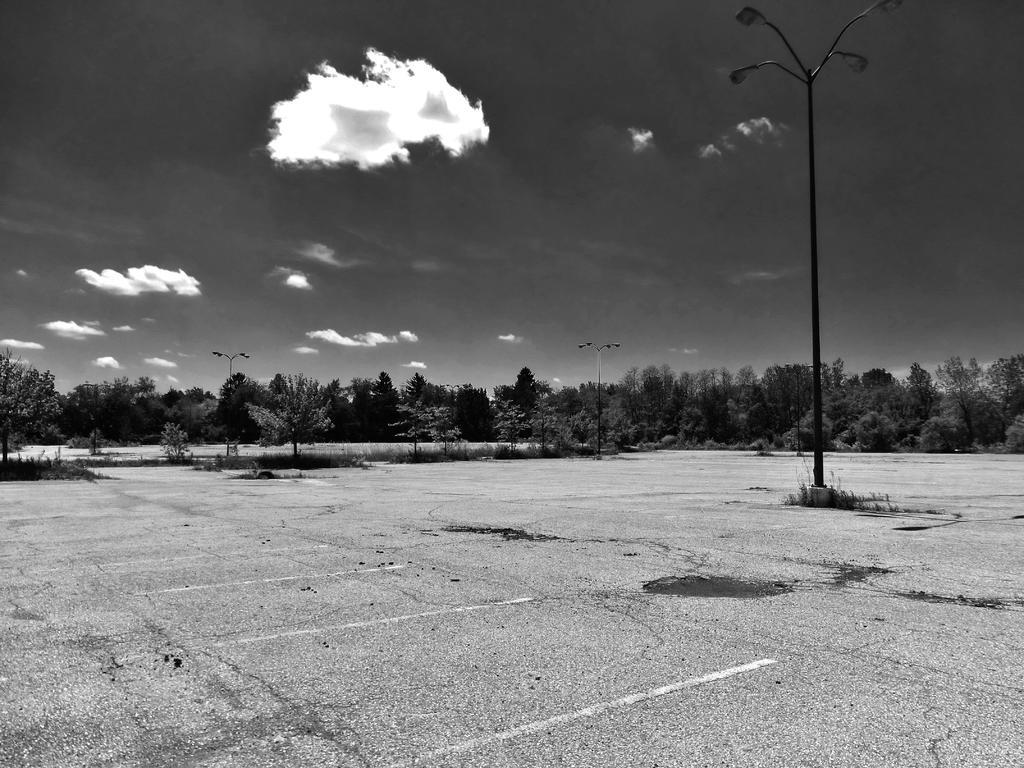What structures are present in the image? There are poles in the image. What else can be seen attached to the poles? There are lights in the image. What type of natural elements are visible in the background of the image? There are trees in the background of the image. What is visible at the top of the image? The sky is visible at the top of the image. How is the image presented in terms of color? The image is black and white. How many legs are visible in the image? There are no legs visible in the image. Is there a veil present in the image? There is no veil present in the image. 